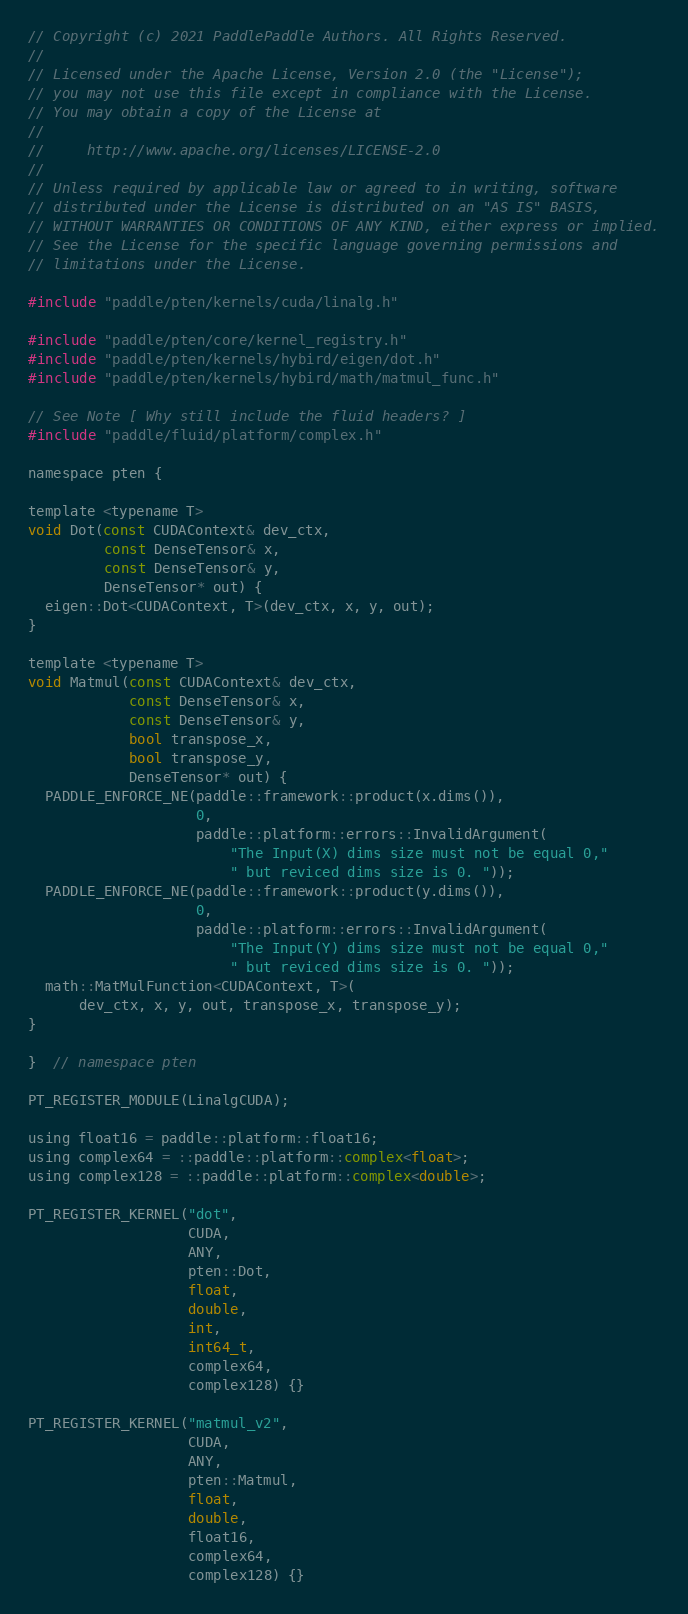Convert code to text. <code><loc_0><loc_0><loc_500><loc_500><_Cuda_>// Copyright (c) 2021 PaddlePaddle Authors. All Rights Reserved.
//
// Licensed under the Apache License, Version 2.0 (the "License");
// you may not use this file except in compliance with the License.
// You may obtain a copy of the License at
//
//     http://www.apache.org/licenses/LICENSE-2.0
//
// Unless required by applicable law or agreed to in writing, software
// distributed under the License is distributed on an "AS IS" BASIS,
// WITHOUT WARRANTIES OR CONDITIONS OF ANY KIND, either express or implied.
// See the License for the specific language governing permissions and
// limitations under the License.

#include "paddle/pten/kernels/cuda/linalg.h"

#include "paddle/pten/core/kernel_registry.h"
#include "paddle/pten/kernels/hybird/eigen/dot.h"
#include "paddle/pten/kernels/hybird/math/matmul_func.h"

// See Note [ Why still include the fluid headers? ]
#include "paddle/fluid/platform/complex.h"

namespace pten {

template <typename T>
void Dot(const CUDAContext& dev_ctx,
         const DenseTensor& x,
         const DenseTensor& y,
         DenseTensor* out) {
  eigen::Dot<CUDAContext, T>(dev_ctx, x, y, out);
}

template <typename T>
void Matmul(const CUDAContext& dev_ctx,
            const DenseTensor& x,
            const DenseTensor& y,
            bool transpose_x,
            bool transpose_y,
            DenseTensor* out) {
  PADDLE_ENFORCE_NE(paddle::framework::product(x.dims()),
                    0,
                    paddle::platform::errors::InvalidArgument(
                        "The Input(X) dims size must not be equal 0,"
                        " but reviced dims size is 0. "));
  PADDLE_ENFORCE_NE(paddle::framework::product(y.dims()),
                    0,
                    paddle::platform::errors::InvalidArgument(
                        "The Input(Y) dims size must not be equal 0,"
                        " but reviced dims size is 0. "));
  math::MatMulFunction<CUDAContext, T>(
      dev_ctx, x, y, out, transpose_x, transpose_y);
}

}  // namespace pten

PT_REGISTER_MODULE(LinalgCUDA);

using float16 = paddle::platform::float16;
using complex64 = ::paddle::platform::complex<float>;
using complex128 = ::paddle::platform::complex<double>;

PT_REGISTER_KERNEL("dot",
                   CUDA,
                   ANY,
                   pten::Dot,
                   float,
                   double,
                   int,
                   int64_t,
                   complex64,
                   complex128) {}

PT_REGISTER_KERNEL("matmul_v2",
                   CUDA,
                   ANY,
                   pten::Matmul,
                   float,
                   double,
                   float16,
                   complex64,
                   complex128) {}
</code> 